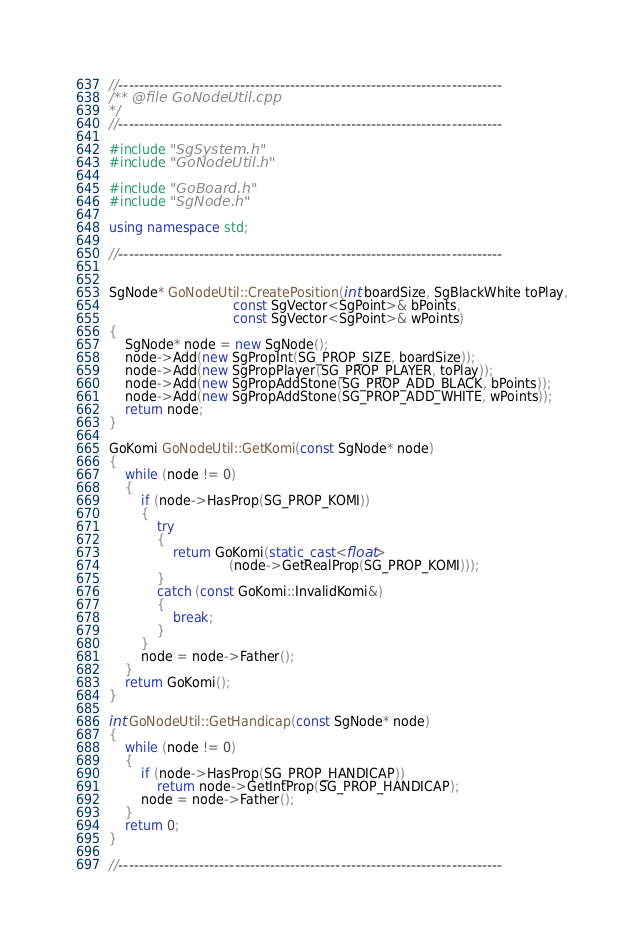Convert code to text. <code><loc_0><loc_0><loc_500><loc_500><_C++_>//----------------------------------------------------------------------------
/** @file GoNodeUtil.cpp
*/
//----------------------------------------------------------------------------

#include "SgSystem.h"
#include "GoNodeUtil.h"

#include "GoBoard.h"
#include "SgNode.h"

using namespace std;

//----------------------------------------------------------------------------


SgNode* GoNodeUtil::CreatePosition(int boardSize, SgBlackWhite toPlay,
                               const SgVector<SgPoint>& bPoints,
                               const SgVector<SgPoint>& wPoints)
{
    SgNode* node = new SgNode();
    node->Add(new SgPropInt(SG_PROP_SIZE, boardSize));
    node->Add(new SgPropPlayer(SG_PROP_PLAYER, toPlay));
    node->Add(new SgPropAddStone(SG_PROP_ADD_BLACK, bPoints));
    node->Add(new SgPropAddStone(SG_PROP_ADD_WHITE, wPoints));
    return node;
}

GoKomi GoNodeUtil::GetKomi(const SgNode* node)
{
    while (node != 0)
    {
        if (node->HasProp(SG_PROP_KOMI))
        {
            try
            {
                return GoKomi(static_cast<float>
                              (node->GetRealProp(SG_PROP_KOMI)));
            }
            catch (const GoKomi::InvalidKomi&)
            {
                break;
            }
        }
        node = node->Father();
    }
    return GoKomi();
}

int GoNodeUtil::GetHandicap(const SgNode* node)
{
    while (node != 0)
    {
        if (node->HasProp(SG_PROP_HANDICAP))
            return node->GetIntProp(SG_PROP_HANDICAP);
        node = node->Father();
    }
    return 0;
}

//----------------------------------------------------------------------------

</code> 